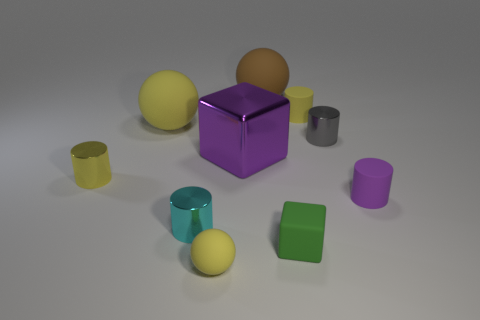What shape is the yellow object that is the same material as the gray object?
Your response must be concise. Cylinder. Is the number of large yellow objects to the right of the purple rubber thing greater than the number of green blocks?
Offer a terse response. No. What number of cylinders are the same color as the tiny cube?
Provide a short and direct response. 0. How many other objects are there of the same color as the tiny matte sphere?
Give a very brief answer. 3. Are there more brown objects than big green matte balls?
Offer a terse response. Yes. What material is the small sphere?
Keep it short and to the point. Rubber. Does the rubber cylinder left of the gray shiny object have the same size as the gray cylinder?
Your answer should be compact. Yes. What size is the shiny thing in front of the small purple matte object?
Your answer should be very brief. Small. Are there any other things that are made of the same material as the big cube?
Offer a very short reply. Yes. What number of purple matte things are there?
Provide a short and direct response. 1. 